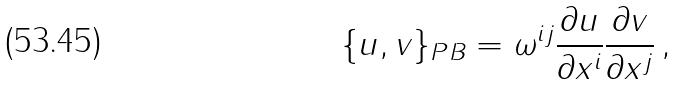Convert formula to latex. <formula><loc_0><loc_0><loc_500><loc_500>\{ u , v \} _ { P B } = \omega ^ { i j } { \frac { \partial u } { \partial x ^ { i } } } { \frac { \partial v } { \partial x ^ { j } } } \, ,</formula> 